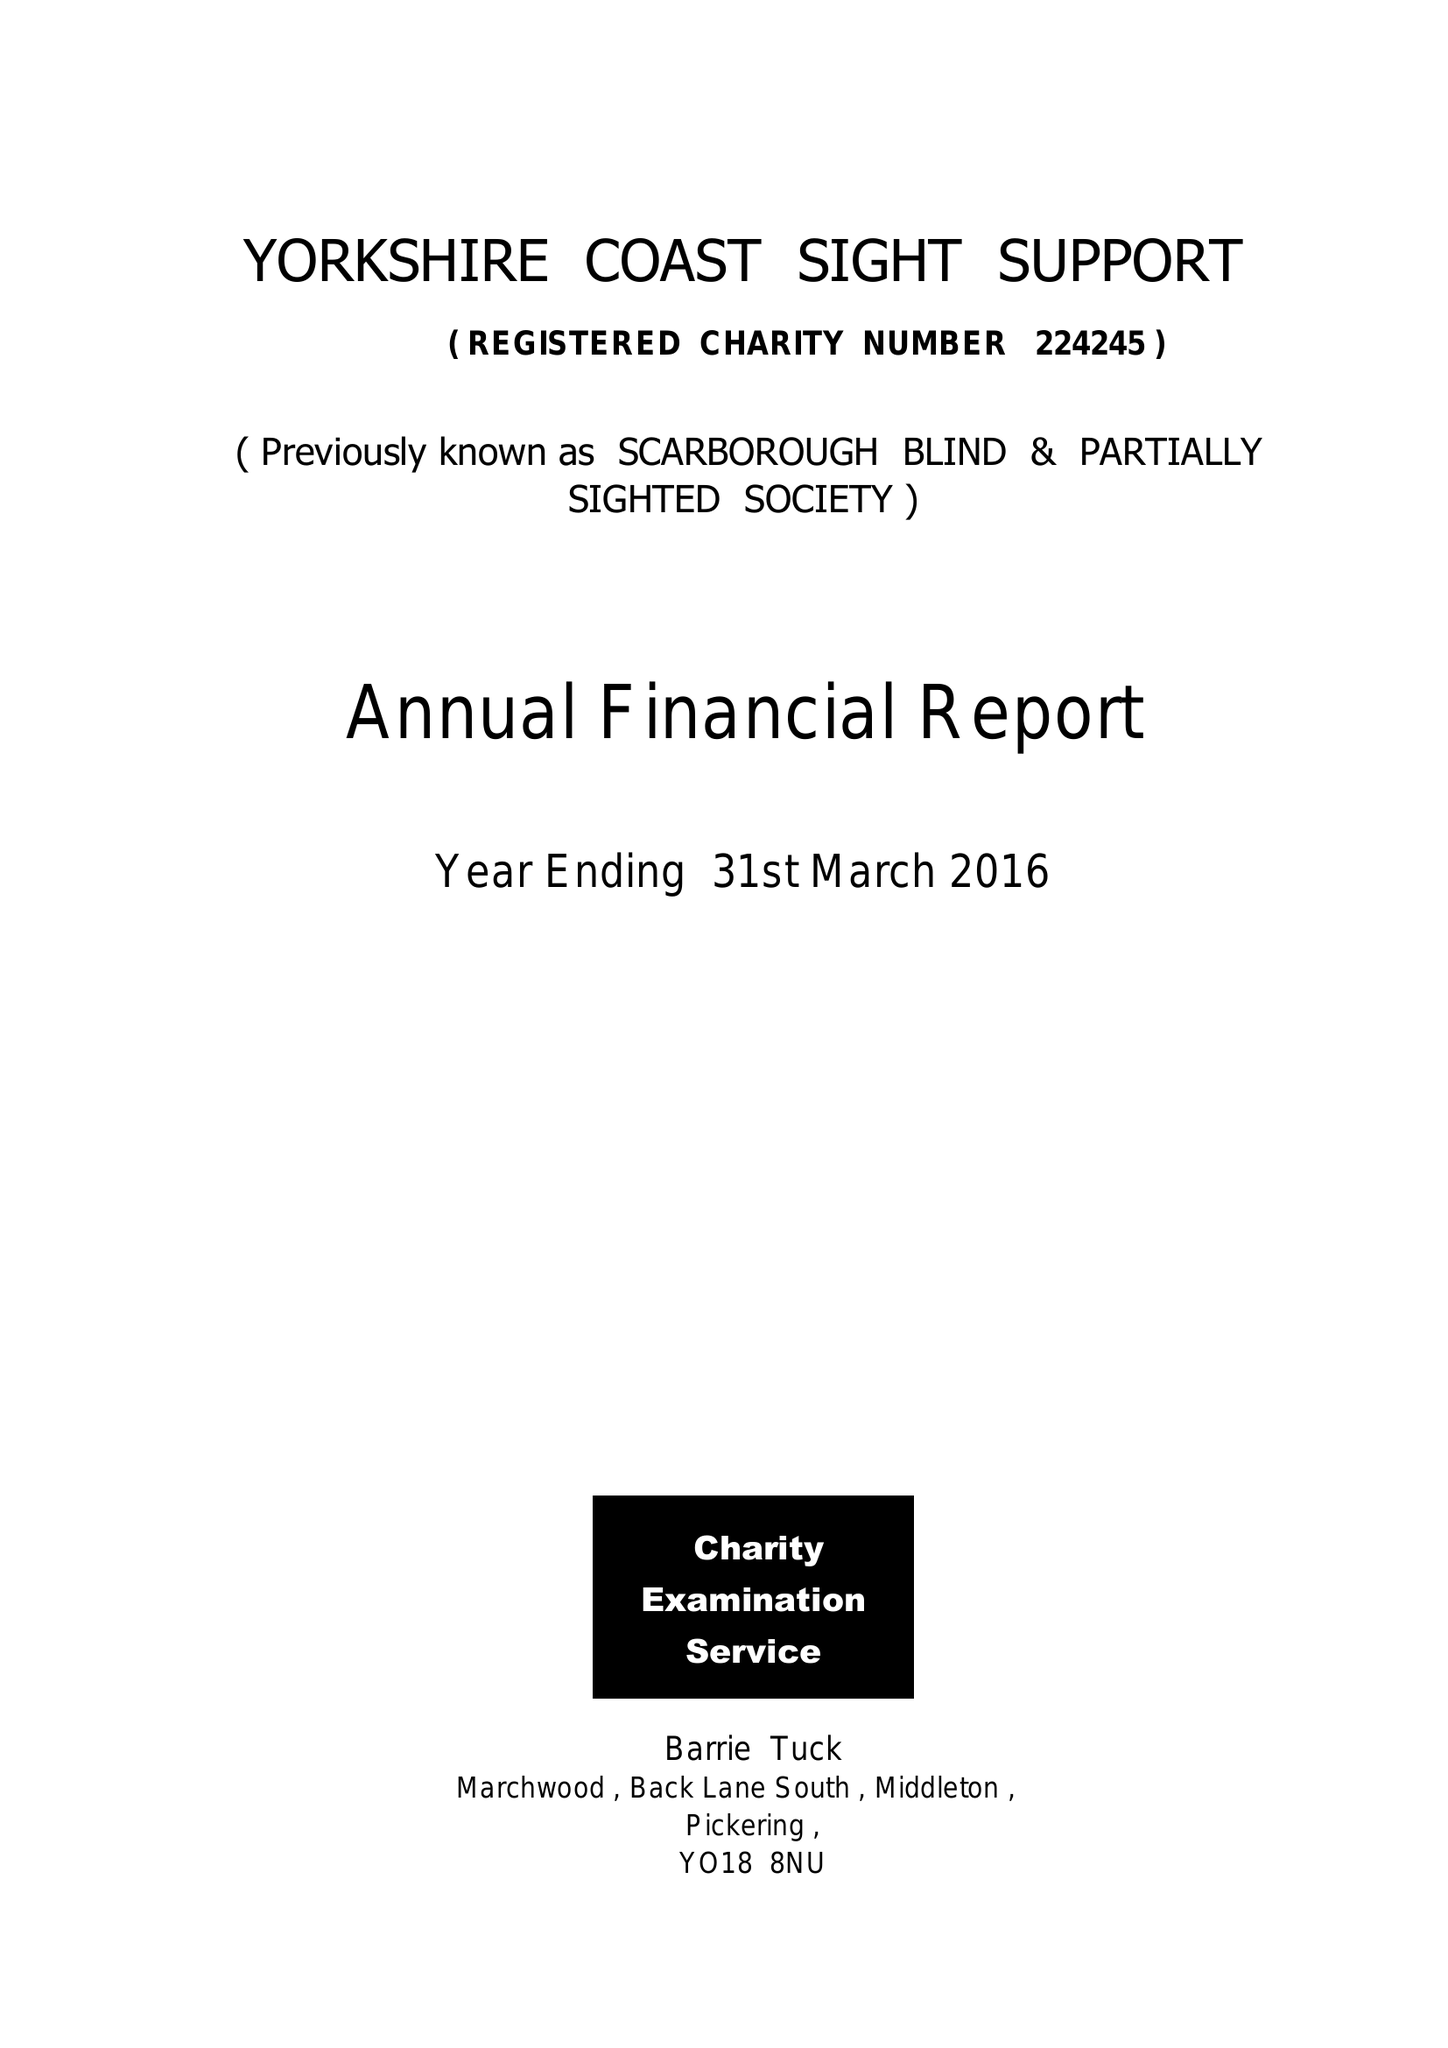What is the value for the charity_name?
Answer the question using a single word or phrase. Yorkshire Coast Sight Support 